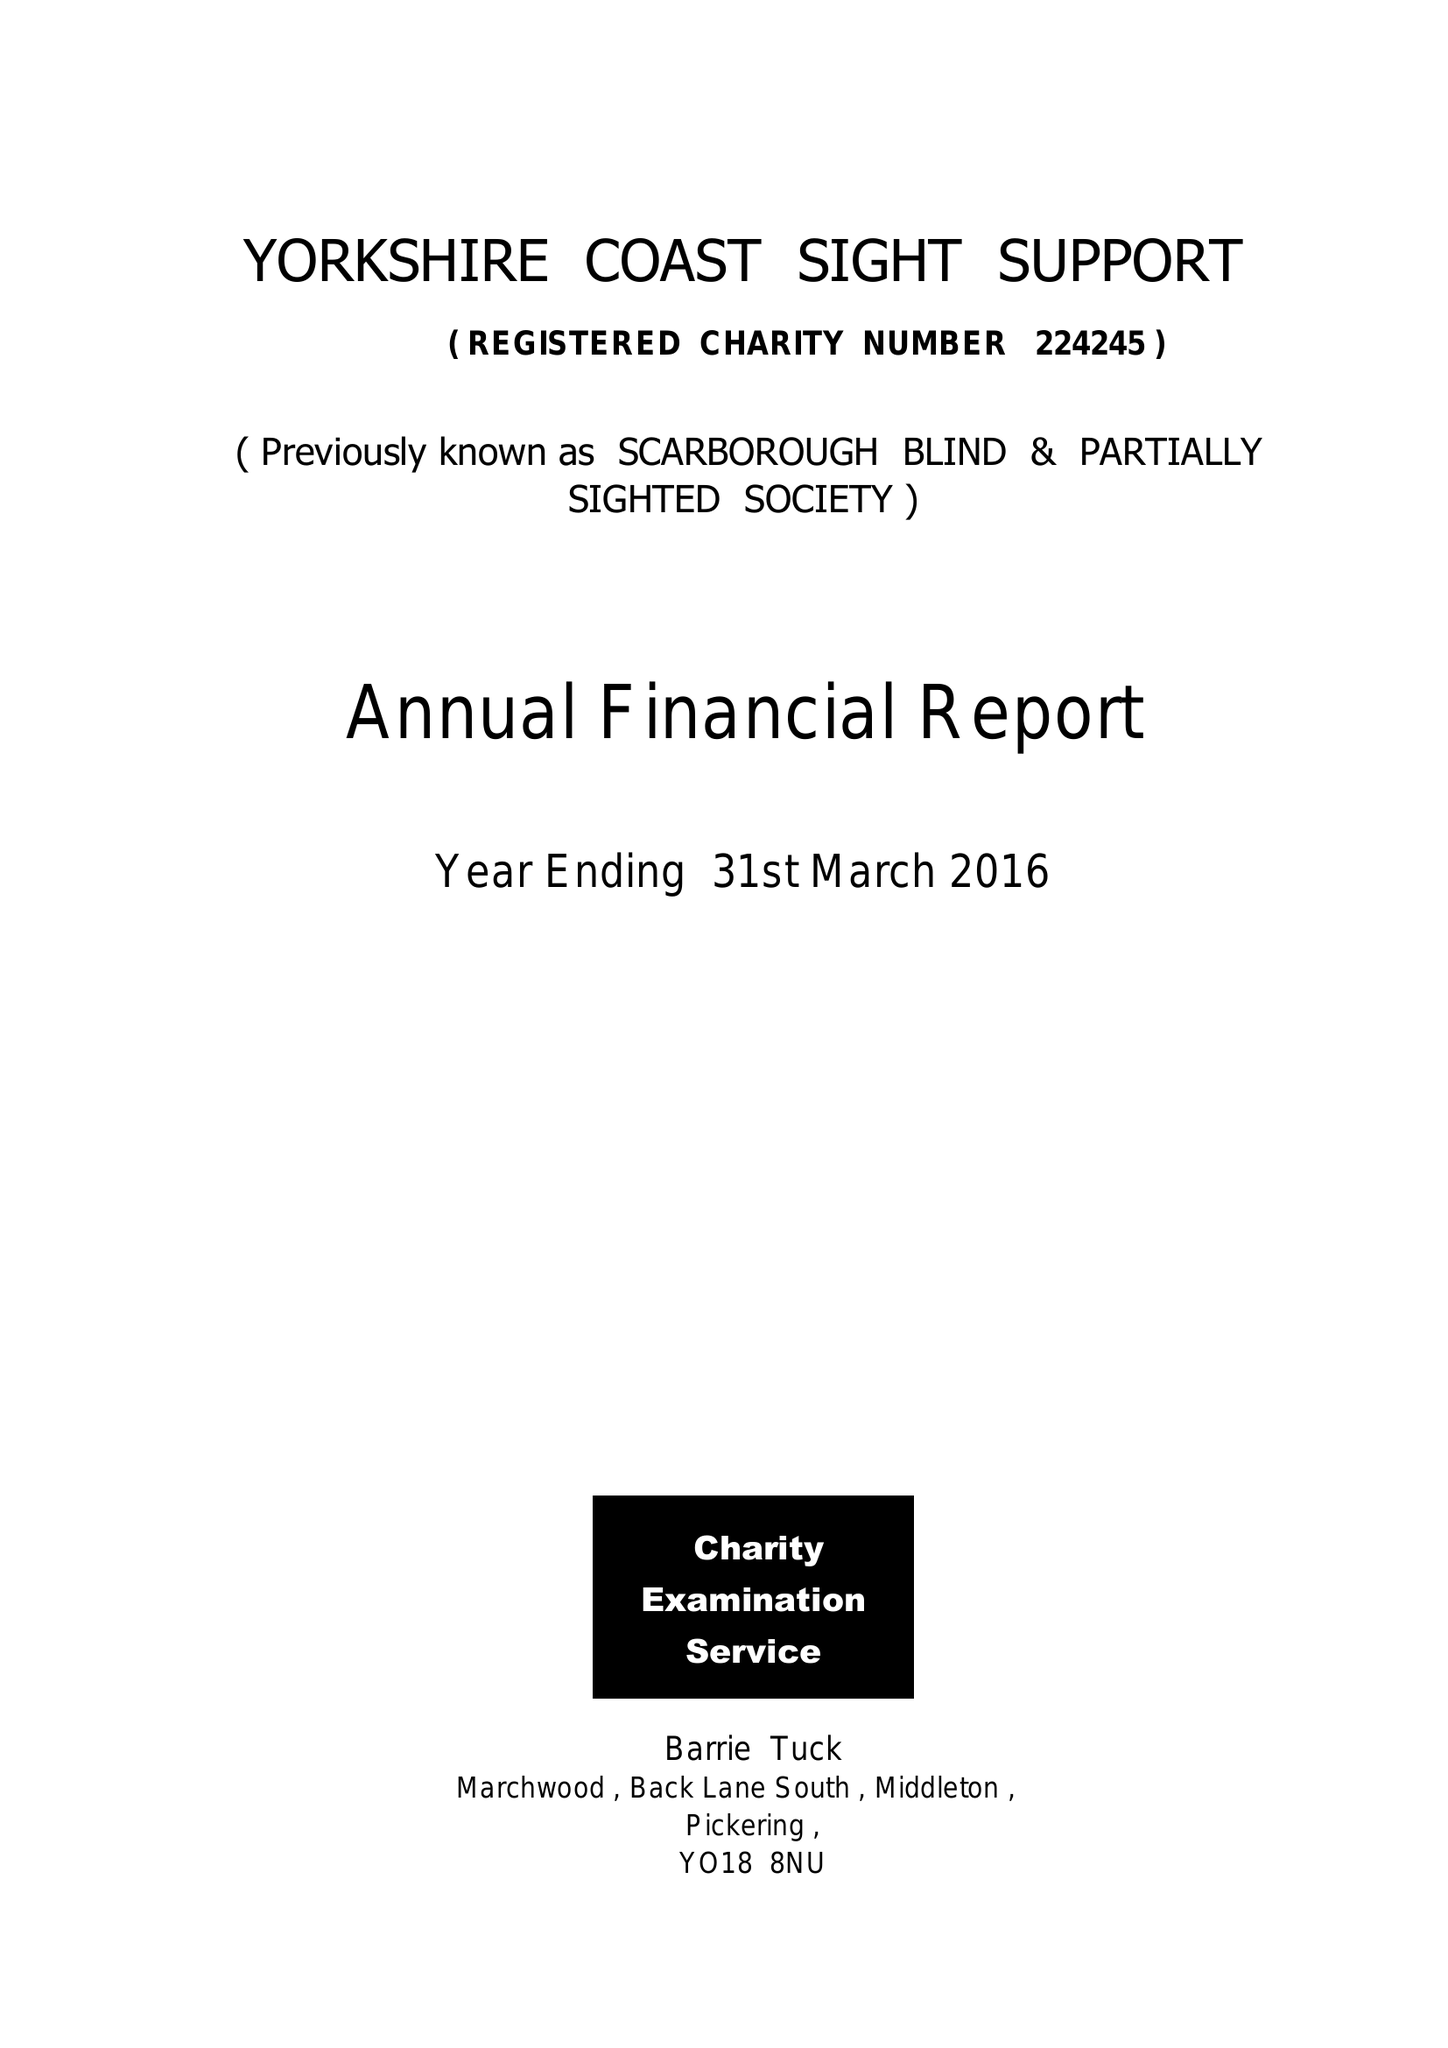What is the value for the charity_name?
Answer the question using a single word or phrase. Yorkshire Coast Sight Support 